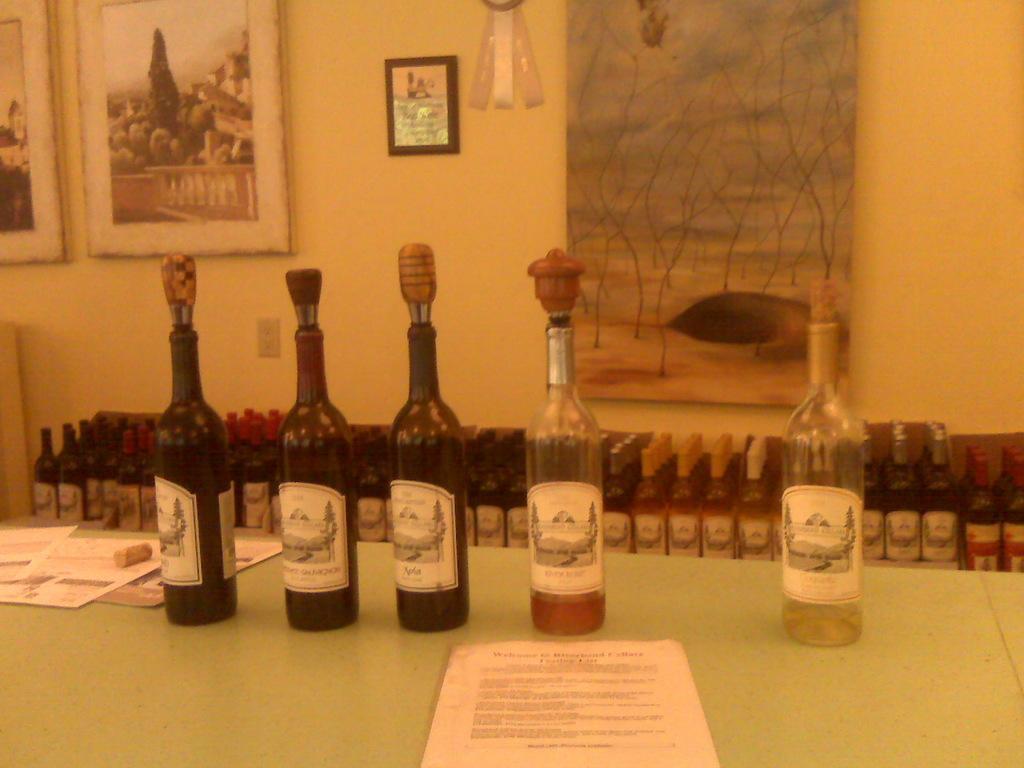Can you describe this image briefly? There are many glass bottles kept on the table with a cork screw above them and in the background we find many bottles placed. There is a painting attached to the wall and there are few photographs fitted. 